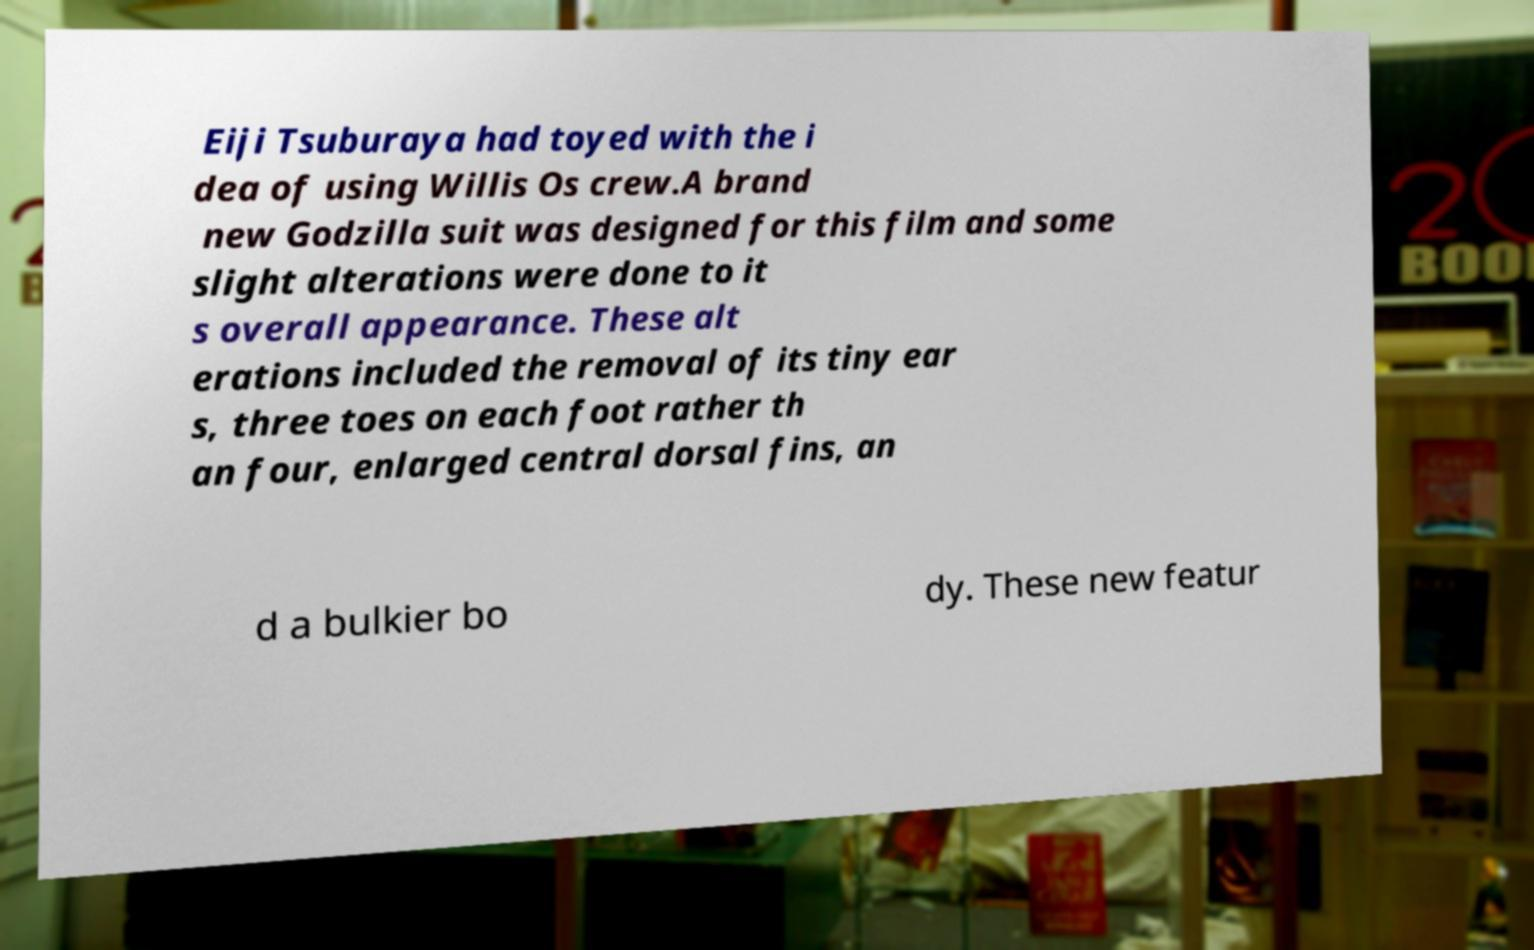I need the written content from this picture converted into text. Can you do that? Eiji Tsuburaya had toyed with the i dea of using Willis Os crew.A brand new Godzilla suit was designed for this film and some slight alterations were done to it s overall appearance. These alt erations included the removal of its tiny ear s, three toes on each foot rather th an four, enlarged central dorsal fins, an d a bulkier bo dy. These new featur 